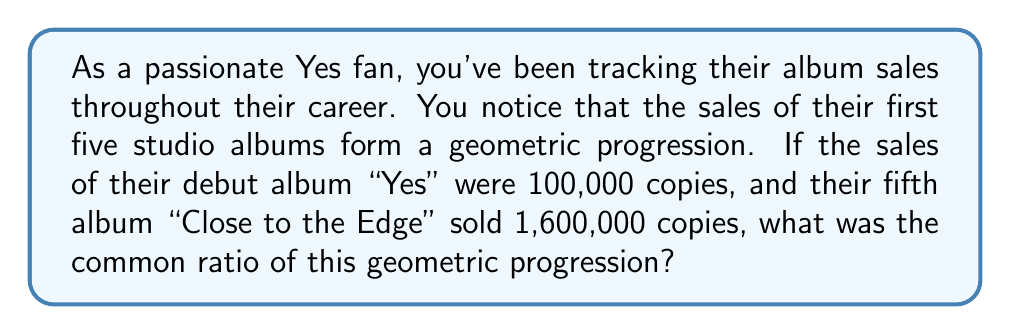Can you answer this question? Let's approach this step-by-step:

1) In a geometric progression, each term is a constant multiple of the previous term. This constant is called the common ratio, r.

2) We're given the first term (a₁) and the fifth term (a₅) of the progression:
   a₁ = 100,000
   a₅ = 1,600,000

3) In a geometric progression, the nth term is given by the formula:
   $a_n = a_1 \cdot r^{n-1}$

4) For the fifth term, this becomes:
   $a_5 = a_1 \cdot r^{4}$

5) Substituting our known values:
   $1,600,000 = 100,000 \cdot r^4$

6) Dividing both sides by 100,000:
   $16 = r^4$

7) To solve for r, we need to take the fourth root of both sides:
   $r = \sqrt[4]{16}$

8) Simplify:
   $r = 2$

Therefore, the common ratio of the geometric progression is 2, meaning each album sold twice as many copies as the previous one.
Answer: 2 